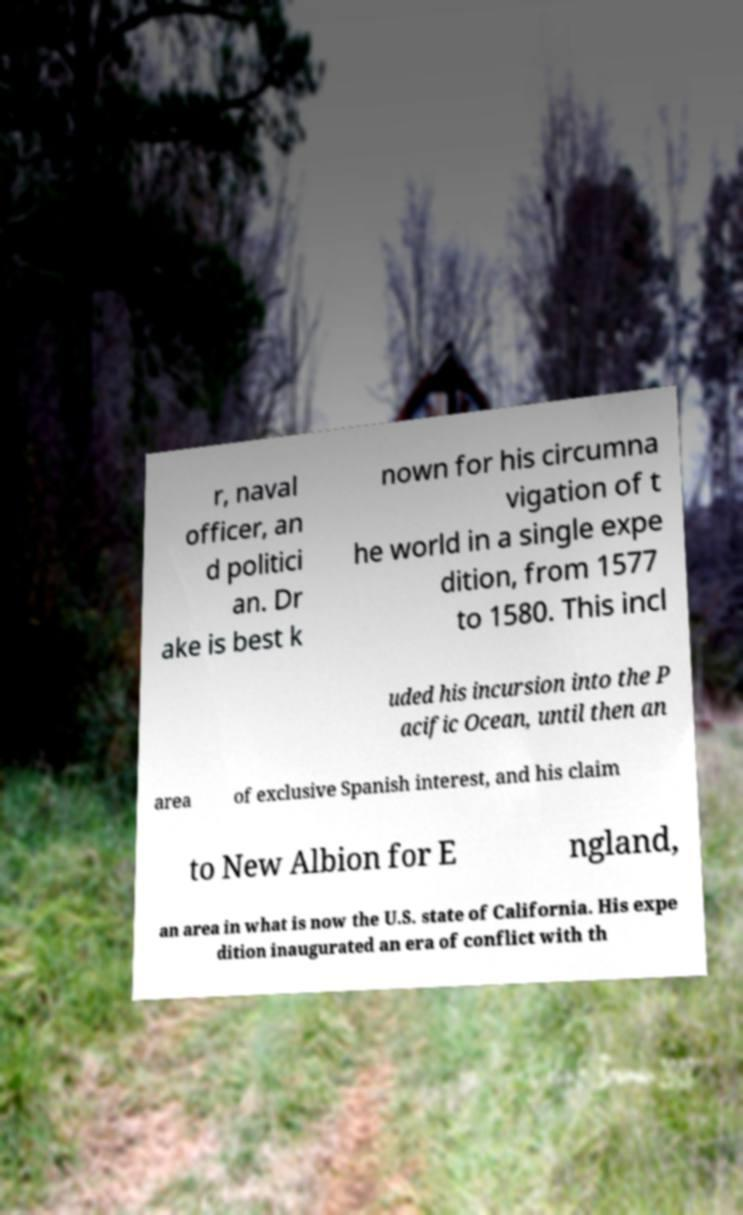Can you read and provide the text displayed in the image?This photo seems to have some interesting text. Can you extract and type it out for me? r, naval officer, an d politici an. Dr ake is best k nown for his circumna vigation of t he world in a single expe dition, from 1577 to 1580. This incl uded his incursion into the P acific Ocean, until then an area of exclusive Spanish interest, and his claim to New Albion for E ngland, an area in what is now the U.S. state of California. His expe dition inaugurated an era of conflict with th 